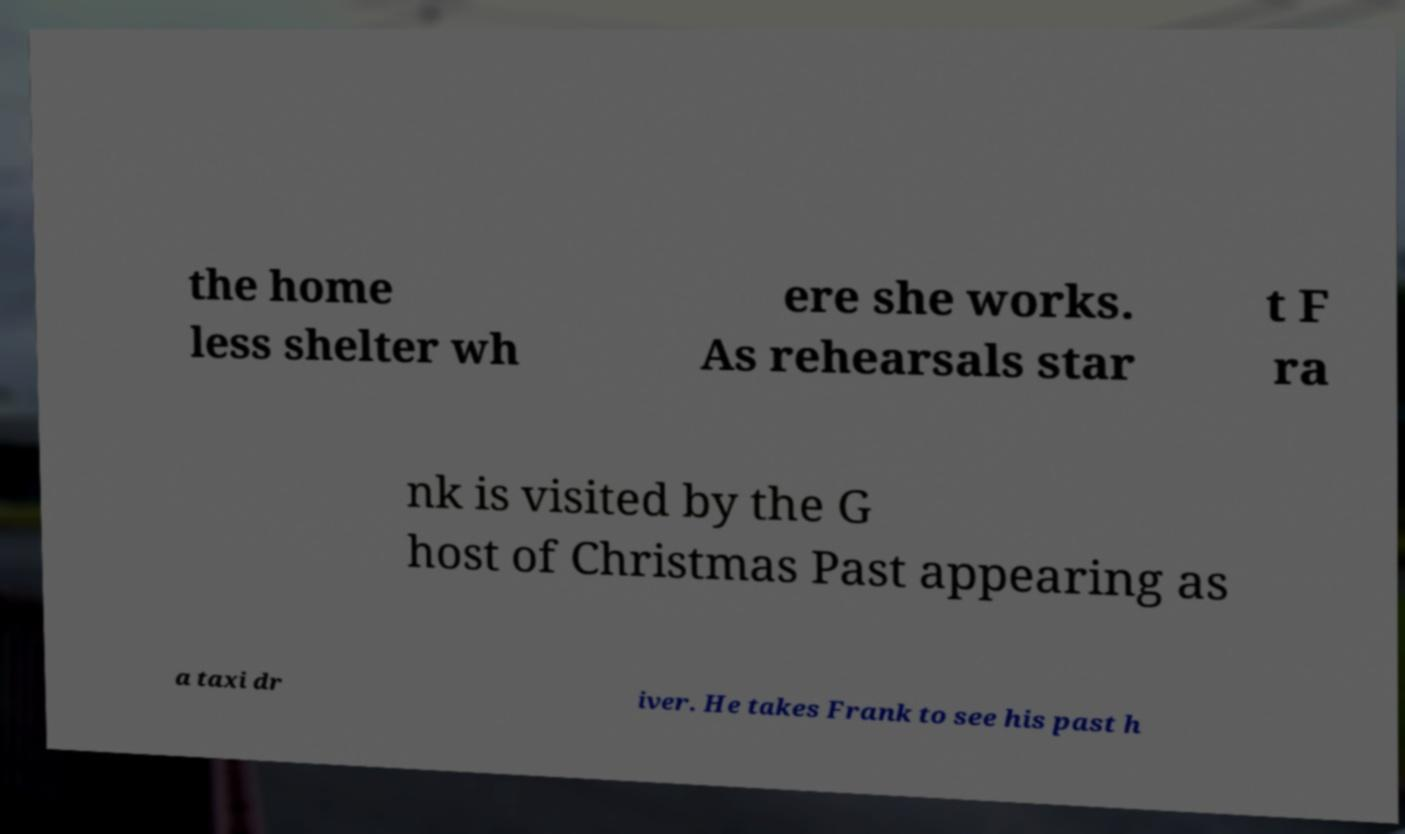There's text embedded in this image that I need extracted. Can you transcribe it verbatim? the home less shelter wh ere she works. As rehearsals star t F ra nk is visited by the G host of Christmas Past appearing as a taxi dr iver. He takes Frank to see his past h 